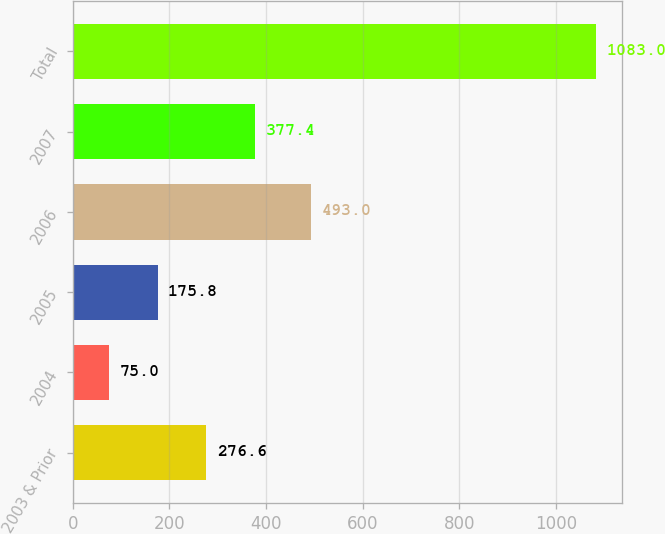Convert chart. <chart><loc_0><loc_0><loc_500><loc_500><bar_chart><fcel>2003 & Prior<fcel>2004<fcel>2005<fcel>2006<fcel>2007<fcel>Total<nl><fcel>276.6<fcel>75<fcel>175.8<fcel>493<fcel>377.4<fcel>1083<nl></chart> 